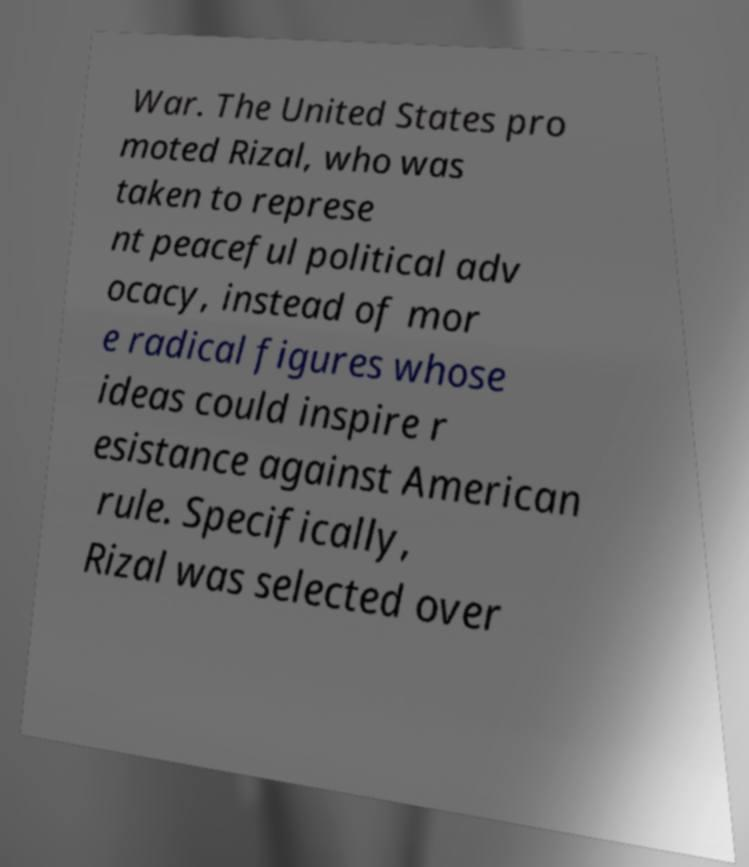I need the written content from this picture converted into text. Can you do that? War. The United States pro moted Rizal, who was taken to represe nt peaceful political adv ocacy, instead of mor e radical figures whose ideas could inspire r esistance against American rule. Specifically, Rizal was selected over 